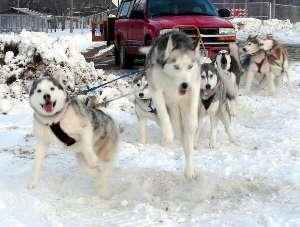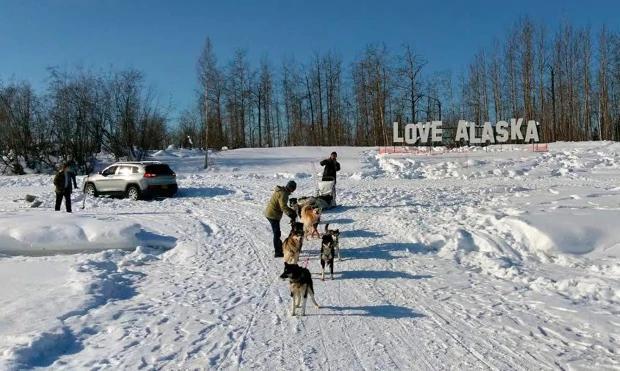The first image is the image on the left, the second image is the image on the right. Assess this claim about the two images: "In the left image there are sled dogs up close pulling straight ahead towards the camera.". Correct or not? Answer yes or no. Yes. 